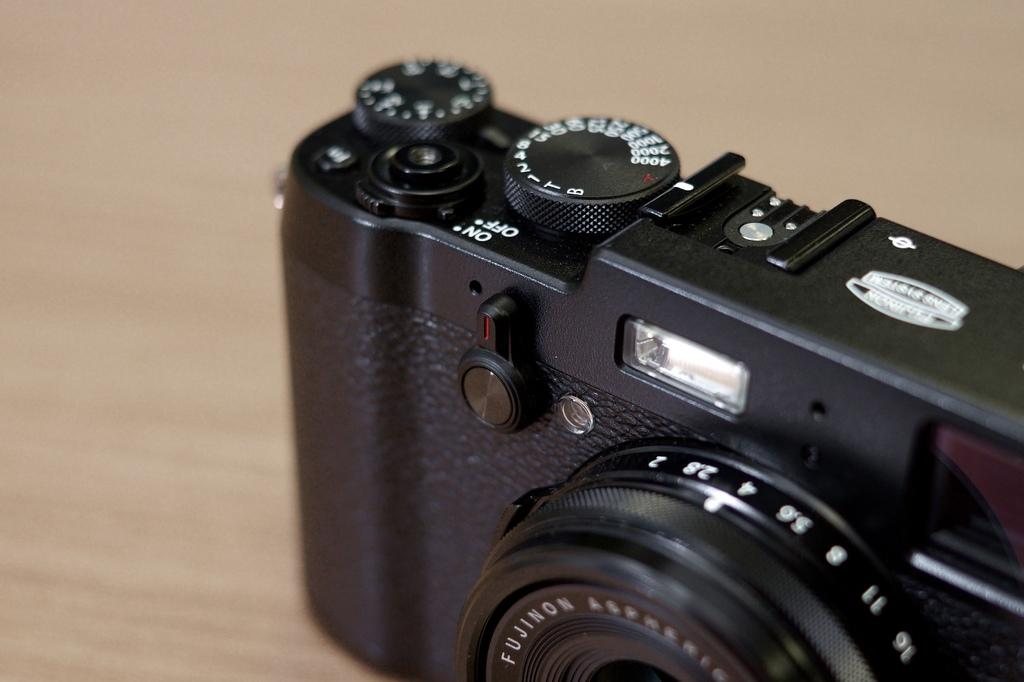Provide a one-sentence caption for the provided image. A SLR camera with an on and off switch. 